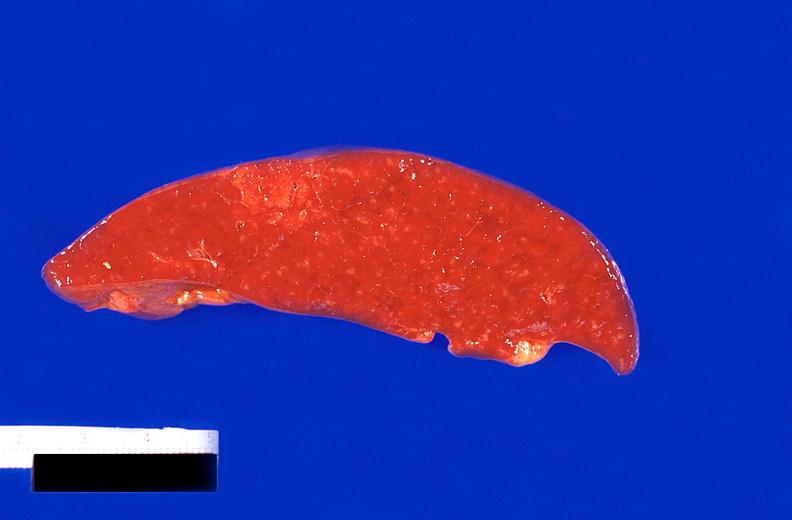what is present?
Answer the question using a single word or phrase. Hematologic 